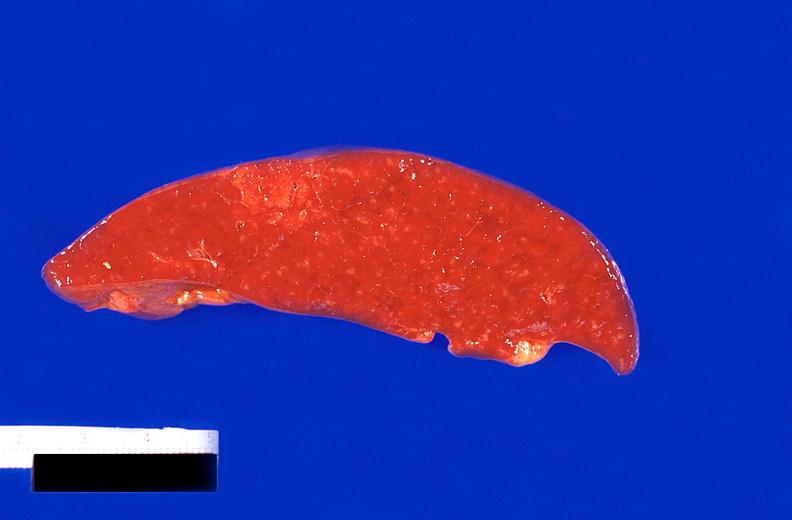what is present?
Answer the question using a single word or phrase. Hematologic 